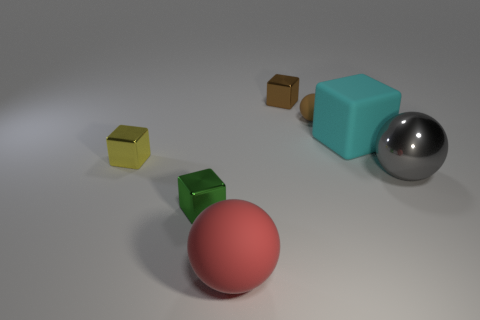Subtract all large cubes. How many cubes are left? 3 Subtract 2 blocks. How many blocks are left? 2 Add 1 big yellow rubber spheres. How many objects exist? 8 Subtract all cyan cubes. How many cubes are left? 3 Subtract all cubes. How many objects are left? 3 Subtract all cyan spheres. Subtract all cyan cylinders. How many spheres are left? 3 Add 4 small green things. How many small green things are left? 5 Add 4 brown spheres. How many brown spheres exist? 5 Subtract 1 brown blocks. How many objects are left? 6 Subtract all big blue metal balls. Subtract all tiny brown shiny things. How many objects are left? 6 